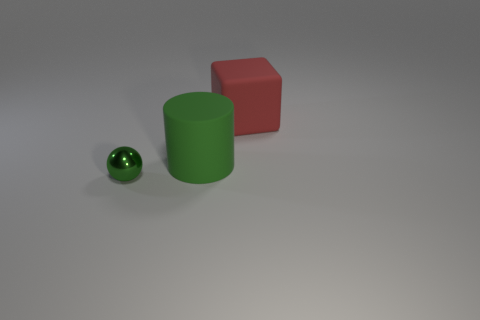Add 3 green shiny spheres. How many objects exist? 6 Subtract 0 cyan blocks. How many objects are left? 3 Subtract all cylinders. How many objects are left? 2 Subtract 1 cubes. How many cubes are left? 0 Subtract all purple balls. Subtract all purple cubes. How many balls are left? 1 Subtract all red matte things. Subtract all matte cubes. How many objects are left? 1 Add 2 red matte cubes. How many red matte cubes are left? 3 Add 1 gray metal spheres. How many gray metal spheres exist? 1 